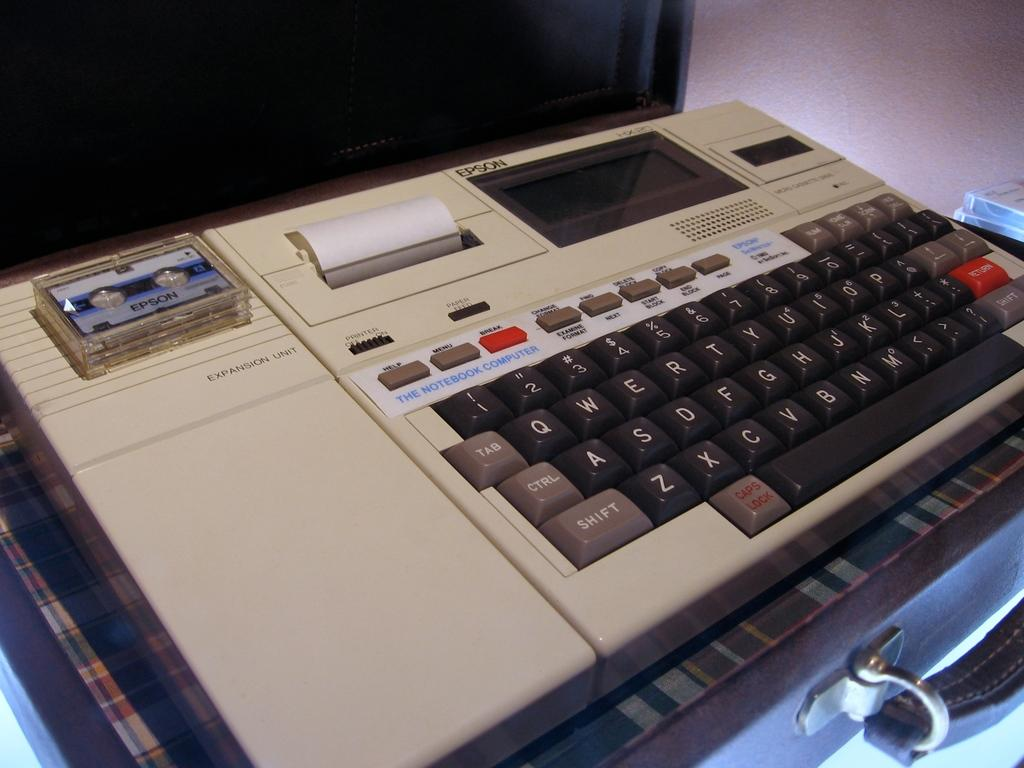Provide a one-sentence caption for the provided image. An old Epson notebook computer sits inside of a briefcase. 